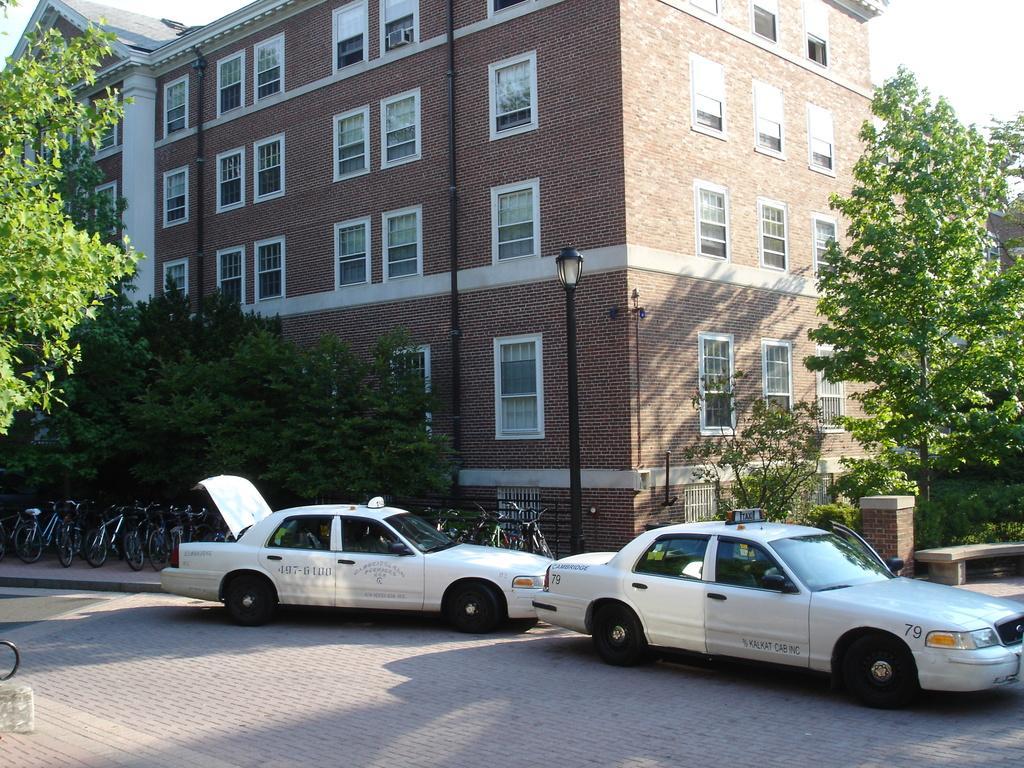Can you describe this image briefly? In this image in the center there are two cars and some cycles, in the background there are buildings, trees, poles, lights. At the bottom there is walkway, and in the background there is a railing. At the top of the image there is sky. 